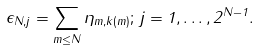Convert formula to latex. <formula><loc_0><loc_0><loc_500><loc_500>\epsilon _ { N , j } = \sum _ { m \leq N } \eta _ { m , k ( m ) } ; \, j = 1 , \dots , 2 ^ { N - 1 } .</formula> 